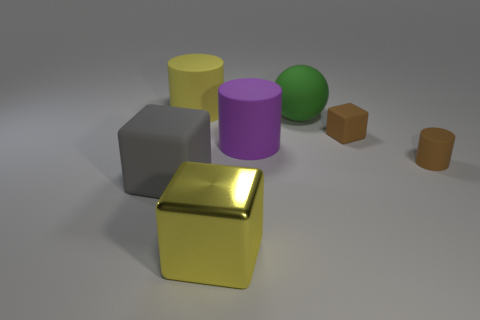Add 3 rubber cylinders. How many objects exist? 10 Subtract all cylinders. How many objects are left? 4 Subtract all blue cylinders. Subtract all cubes. How many objects are left? 4 Add 4 big green rubber objects. How many big green rubber objects are left? 5 Add 3 brown rubber blocks. How many brown rubber blocks exist? 4 Subtract 1 green spheres. How many objects are left? 6 